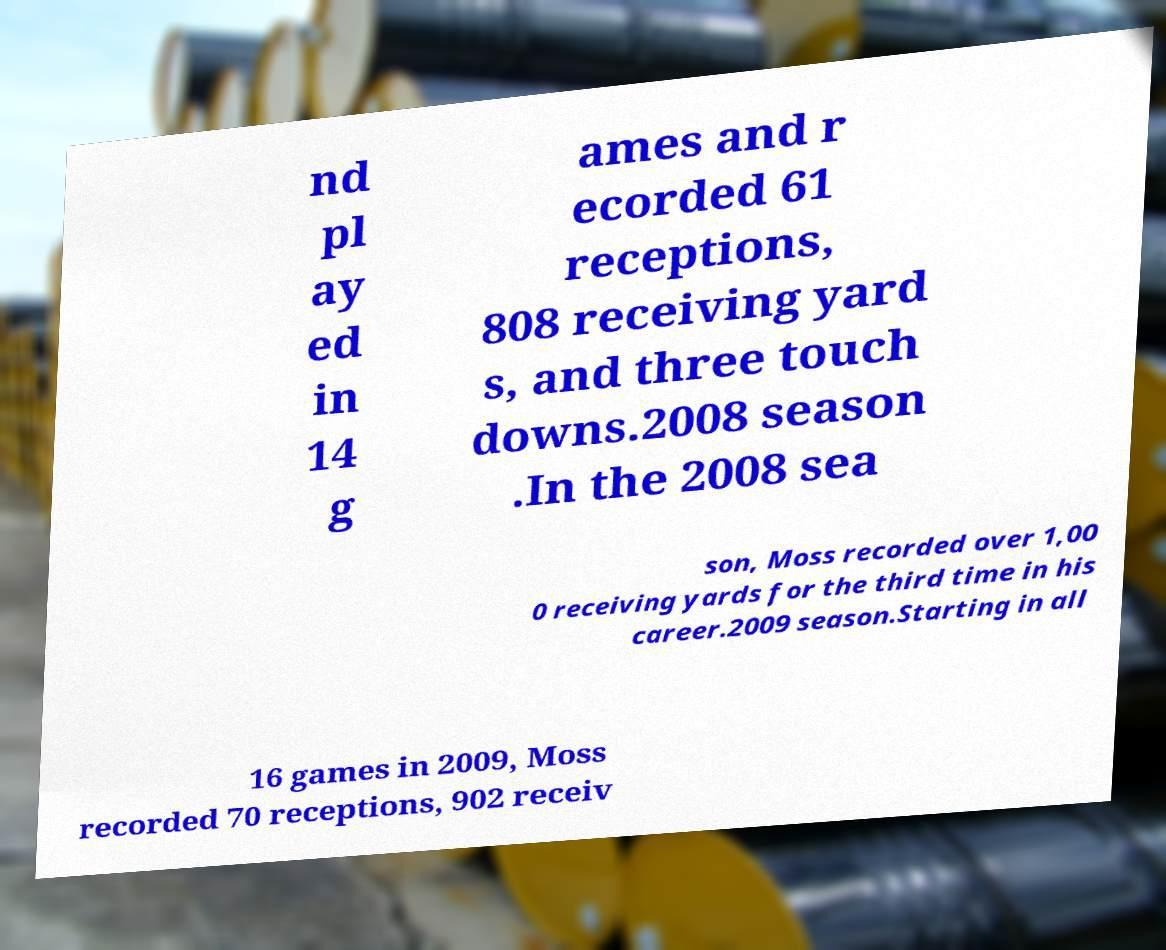For documentation purposes, I need the text within this image transcribed. Could you provide that? nd pl ay ed in 14 g ames and r ecorded 61 receptions, 808 receiving yard s, and three touch downs.2008 season .In the 2008 sea son, Moss recorded over 1,00 0 receiving yards for the third time in his career.2009 season.Starting in all 16 games in 2009, Moss recorded 70 receptions, 902 receiv 